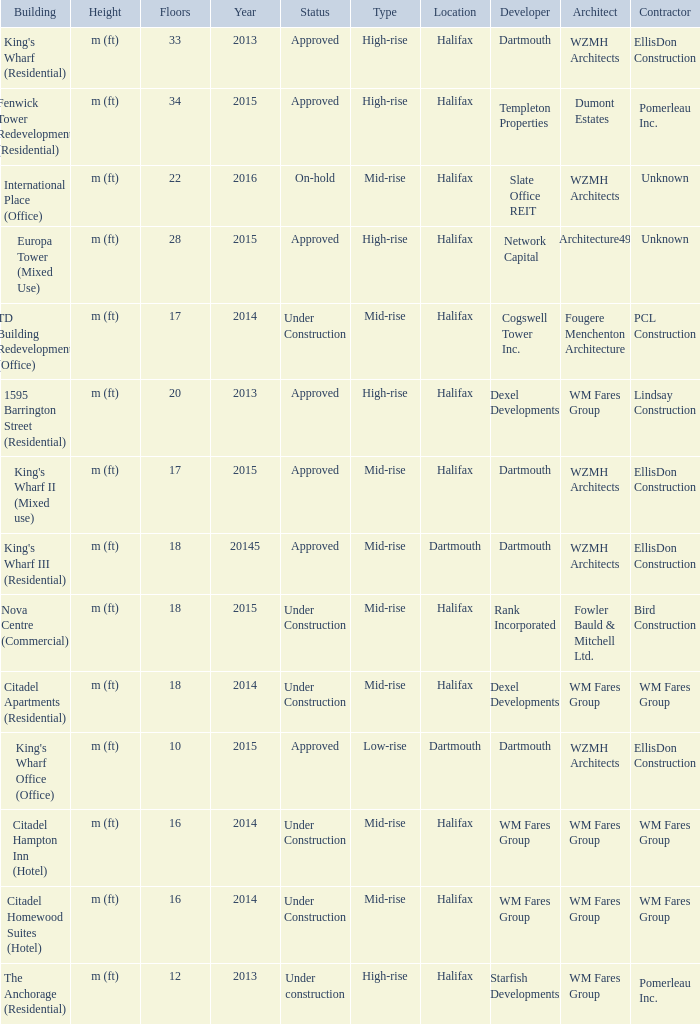What is the status of the building with more than 28 floor and a year of 2013? Approved. 